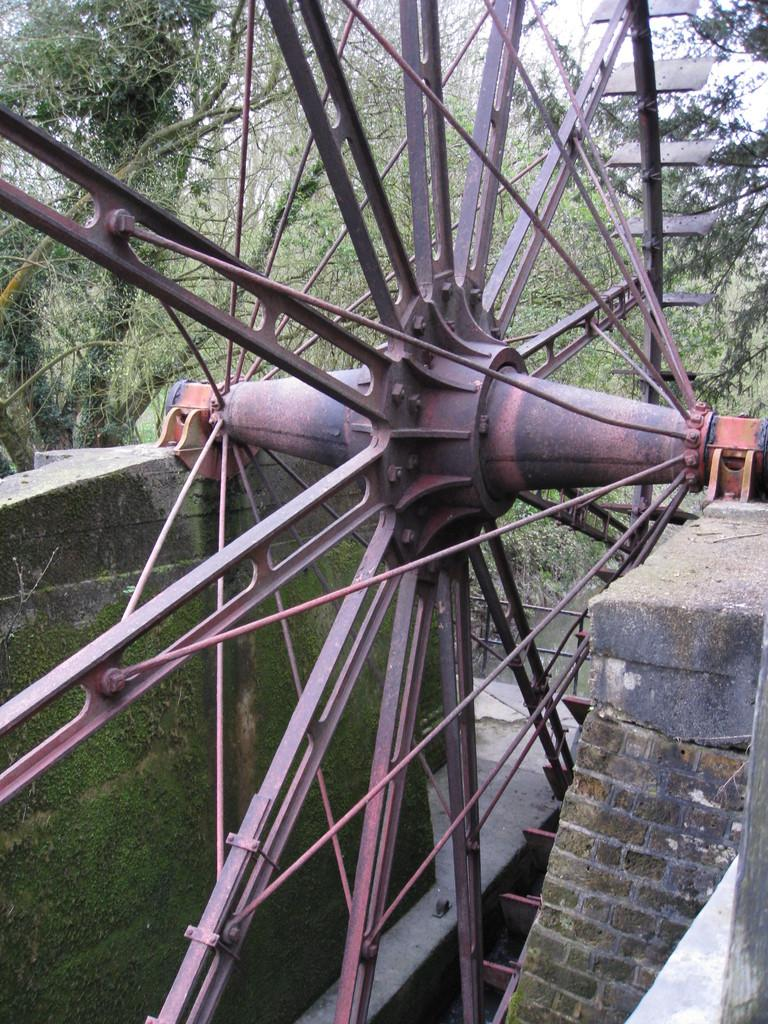What is the main subject of the picture? The main subject of the picture is a huge wheel. What material is used for the frames of the wheel? The wheel has iron frames. Where is the wheel located in relation to the walls? The wheel is placed between two walls. What can be seen in the background of the picture? Trees and the sky are visible in the background. What type of approval is required for the bushes in the image? There are no bushes present in the image, so no approval is required. Can you tell me how many trees are depicted in the image? The image contains trees in the backdrop, but the exact number cannot be determined from the image. 